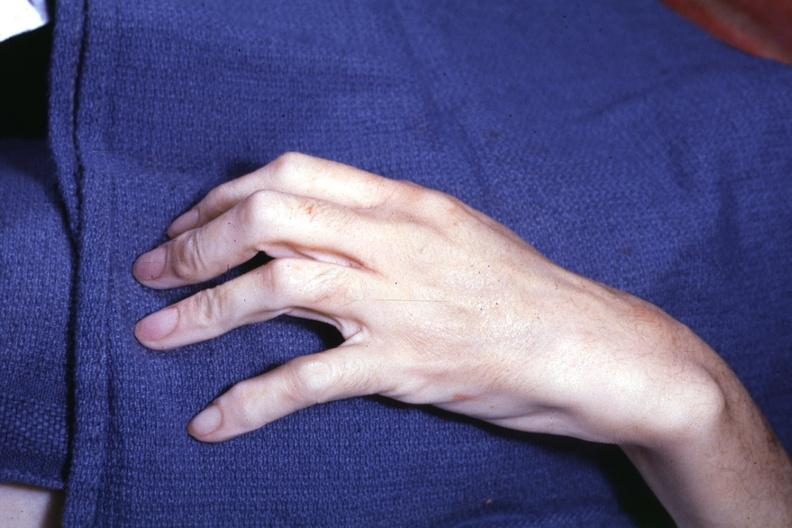s arachnodactyly present?
Answer the question using a single word or phrase. Yes 